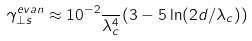<formula> <loc_0><loc_0><loc_500><loc_500>\gamma _ { \perp s } ^ { e v a n } \approx 1 0 ^ { - 2 } \frac { } { \lambda _ { c } ^ { 4 } } ( 3 - 5 \ln ( 2 d / \lambda _ { c } ) )</formula> 